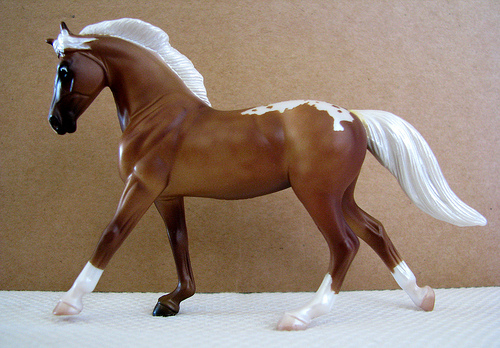<image>
Can you confirm if the horse is on the table? Yes. Looking at the image, I can see the horse is positioned on top of the table, with the table providing support. 